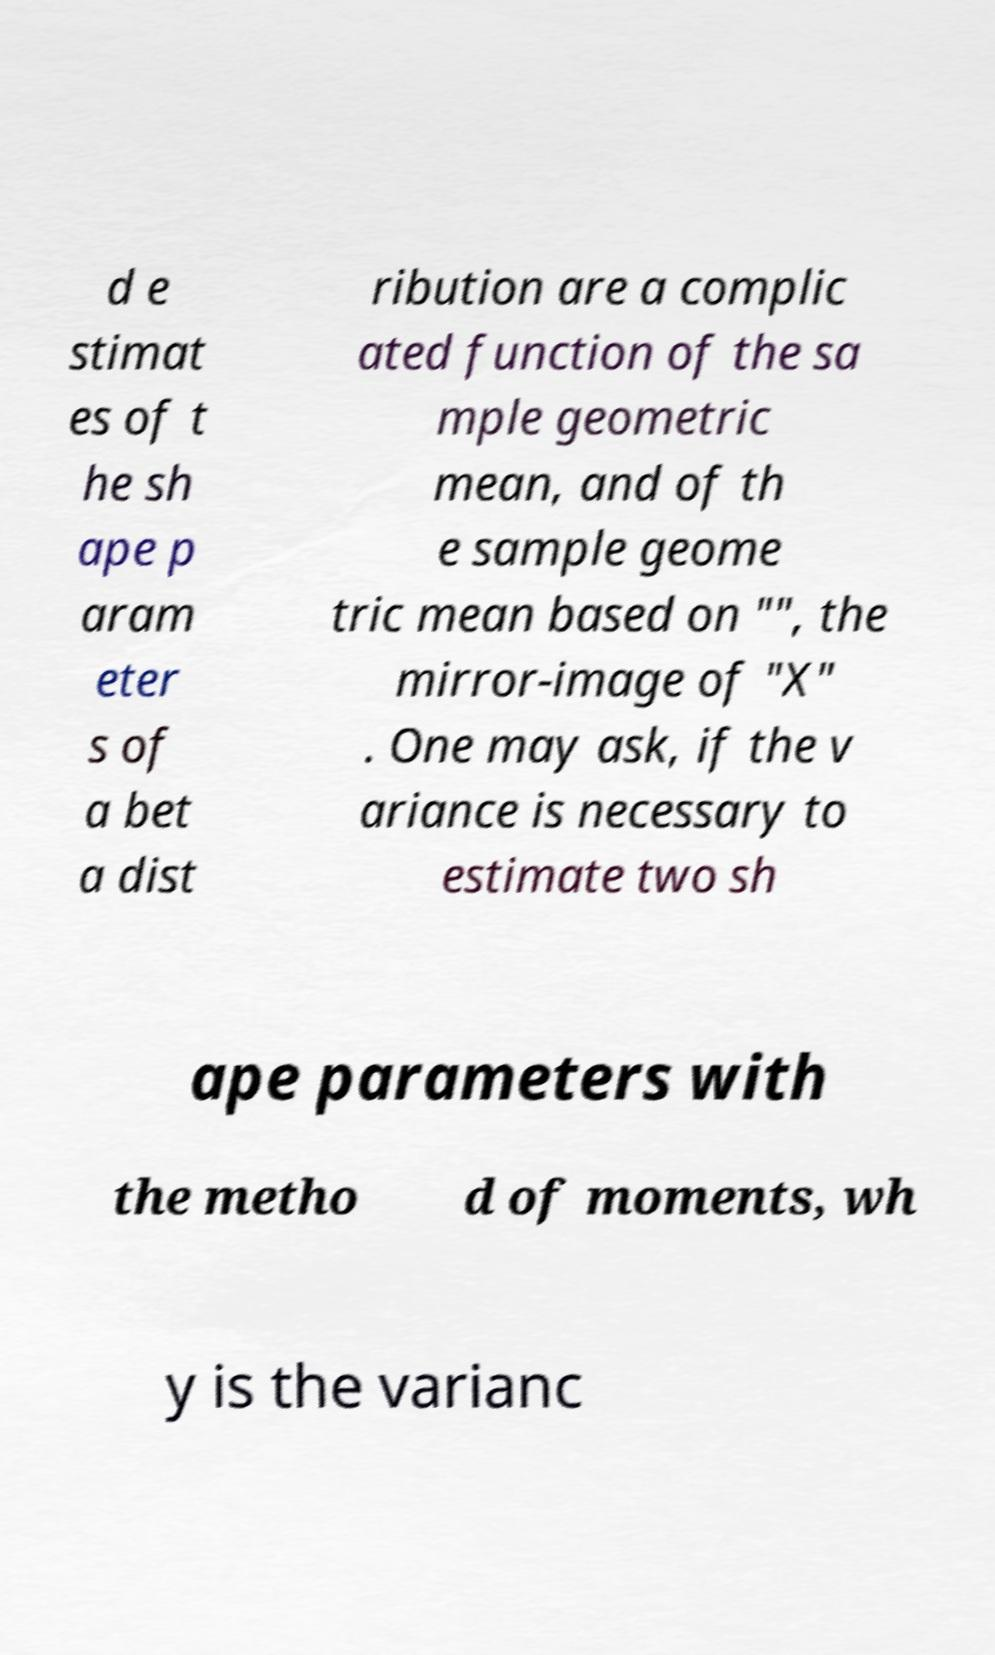Could you assist in decoding the text presented in this image and type it out clearly? d e stimat es of t he sh ape p aram eter s of a bet a dist ribution are a complic ated function of the sa mple geometric mean, and of th e sample geome tric mean based on "", the mirror-image of "X" . One may ask, if the v ariance is necessary to estimate two sh ape parameters with the metho d of moments, wh y is the varianc 